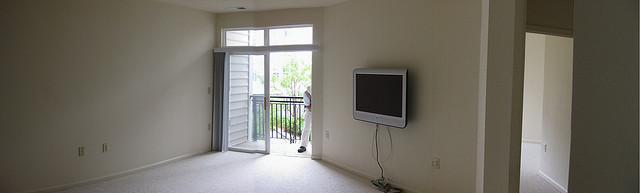Are the patio doors open?
Give a very brief answer. Yes. How many red bags are in the picture?
Answer briefly. 0. Is this room well appointed?
Be succinct. No. Is there anything on the wall?
Short answer required. Yes. 